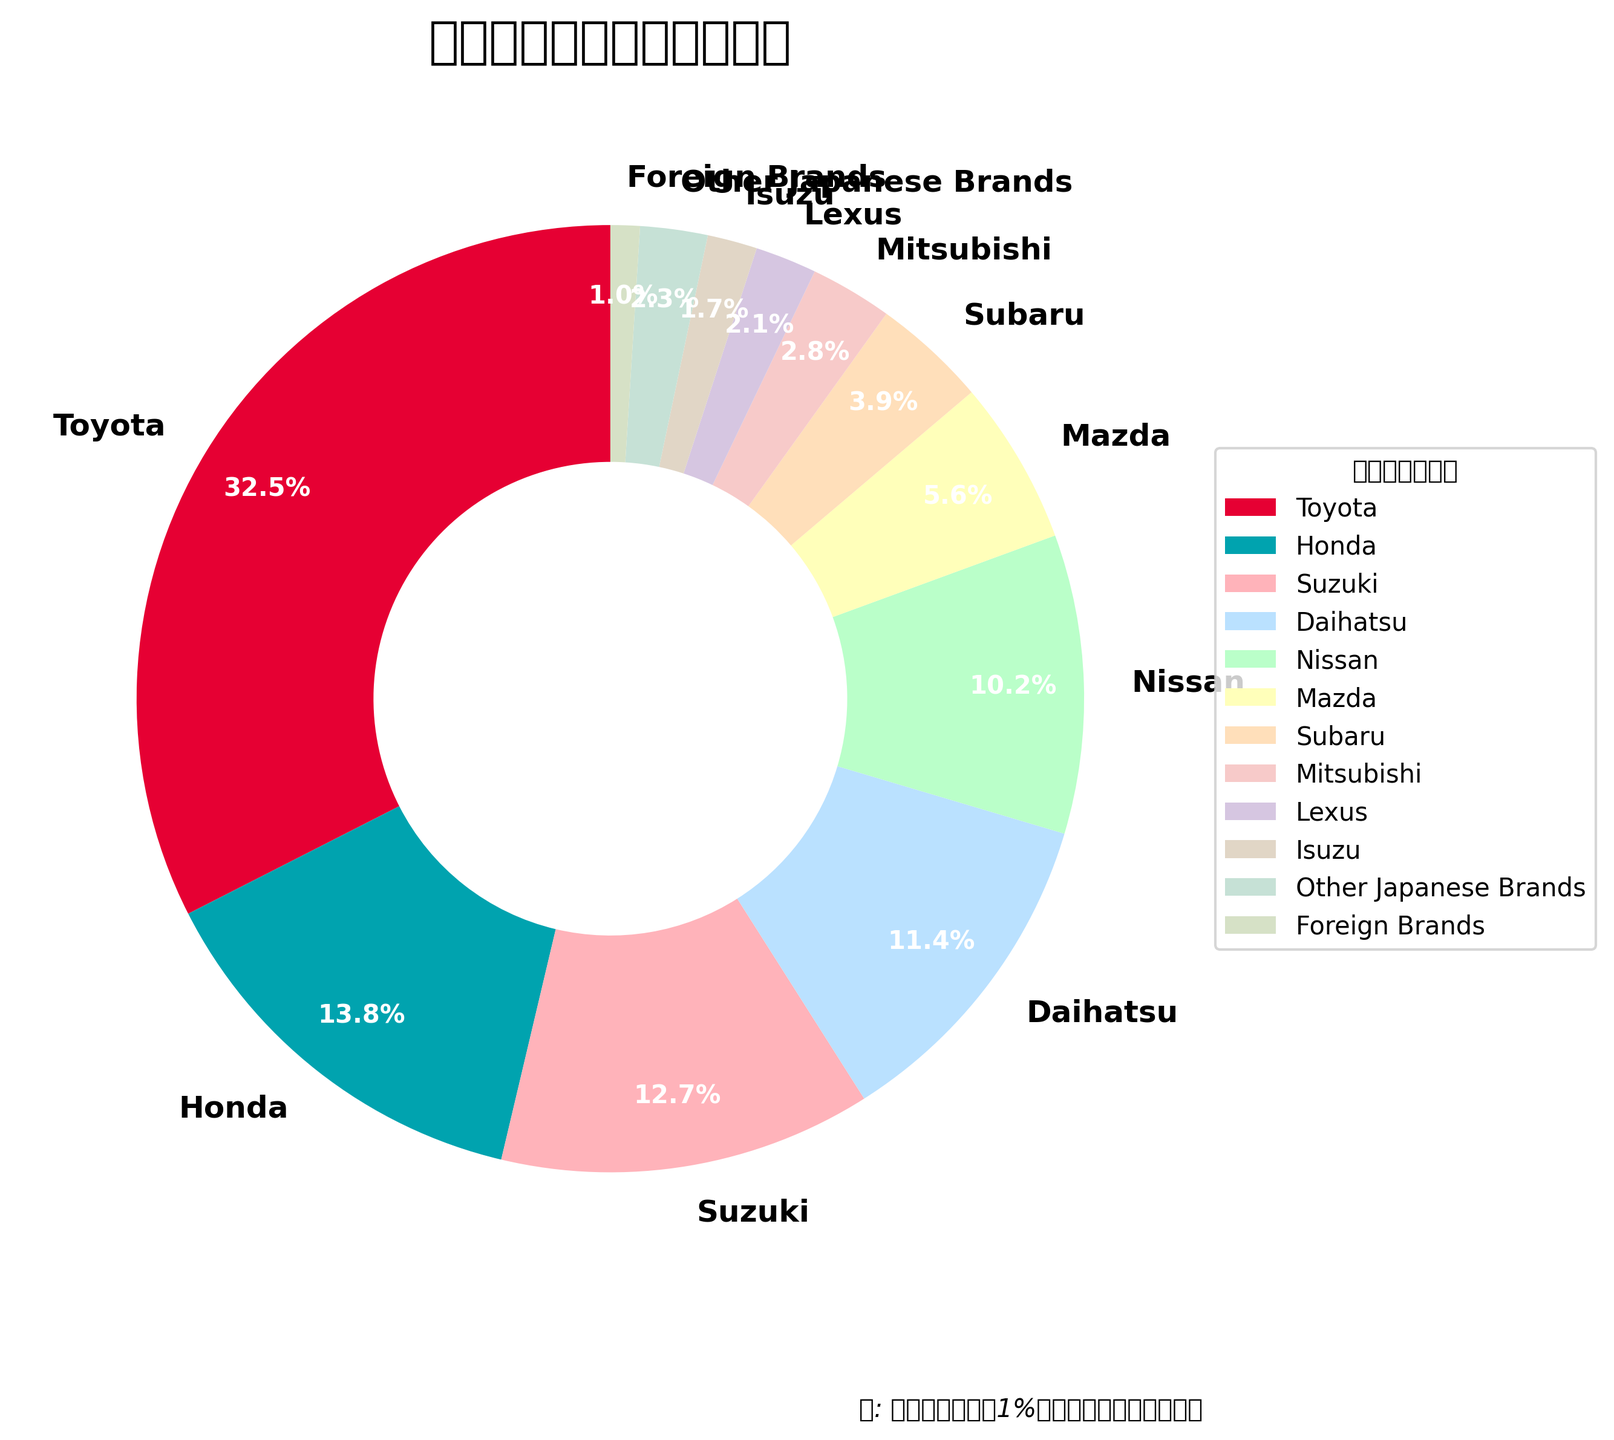Which manufacturer has the highest market share? The figure shows different pie slices for each manufacturer, with Toyota having the largest one.
Answer: Toyota What is the total market share of Honda and Nissan combined? Add the market shares of Honda (13.8%) and Nissan (10.2%). 13.8 + 10.2 = 24.0
Answer: 24.0% Which manufacturer has a greater market share: Mazda or Subaru? By comparing the pie slices labeled Mazda (5.6%) and Subaru (3.9%), we see that Mazda's share is larger.
Answer: Mazda What is the difference in market share between Toyota and Honda? Subtract Honda's market share (13.8%) from Toyota's market share (32.5%). 32.5 - 13.8 = 18.7
Answer: 18.7% How many manufacturers have a market share greater than 10%? By looking at the pie chart, we can see that Toyota, Honda, Suzuki, and Daihatsu have shares greater than 10%.
Answer: 4 What is the combined market share of brands with less than 5% market share each? Add the market shares of Mazda (5.6%), Subaru (3.9%), Mitsubishi (2.8%), Lexus (2.1%), Isuzu (1.7%), Other Japanese Brands (2.3%), and Foreign Brands (1.0%). Note that Mazda's share is above 5%, so we exclude it. 3.9 + 2.8 + 2.1 + 1.7 + 2.3 + 1.0 = 13.8
Answer: 13.8% Which manufacturer has the smallest market share, and what is it? The smallest slice belongs to Foreign Brands, which is labeled with a 1.0% market share.
Answer: Foreign Brands, 1.0% By how much does Subaru's market share exceed Mitsubishi's? Subtract Mitsubishi's market share (2.8%) from Subaru's market share (3.9%). 3.9 - 2.8 = 1.1
Answer: 1.1% What is the market share of the three smallest manufacturers combined? Combine the market shares of Mitsubishi (2.8%), Lexus (2.1%), and Isuzu (1.7%). 2.8 + 2.1 + 1.7 = 6.6
Answer: 6.6% What is the average market share of the top 3 manufacturers? Calculate the average of the market shares of the top 3 manufacturers: Toyota (32.5%), Honda (13.8%), and Suzuki (12.7%). (32.5 + 13.8 + 12.7) / 3 = 19.67
Answer: 19.67% 